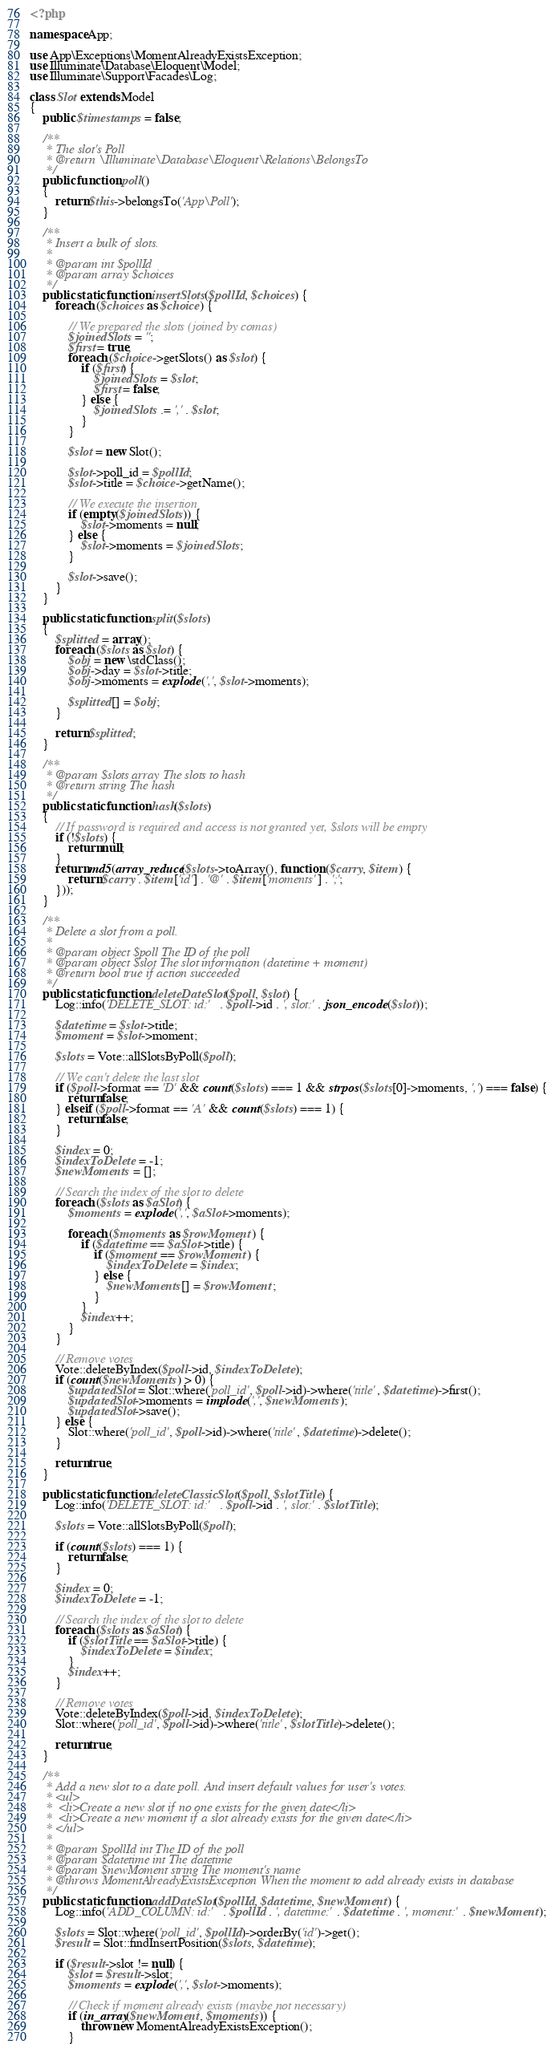<code> <loc_0><loc_0><loc_500><loc_500><_PHP_><?php

namespace App;

use App\Exceptions\MomentAlreadyExistsException;
use Illuminate\Database\Eloquent\Model;
use Illuminate\Support\Facades\Log;

class Slot extends Model
{
    public $timestamps = false;

    /**
     * The slot's Poll
     * @return \Illuminate\Database\Eloquent\Relations\BelongsTo
     */
    public function poll()
    {
        return $this->belongsTo('App\Poll');
    }

    /**
     * Insert a bulk of slots.
     *
     * @param int $pollId
     * @param array $choices
     */
    public static function insertSlots($pollId, $choices) {
        foreach ($choices as $choice) {

            // We prepared the slots (joined by comas)
            $joinedSlots = '';
            $first = true;
            foreach ($choice->getSlots() as $slot) {
                if ($first) {
                    $joinedSlots = $slot;
                    $first = false;
                } else {
                    $joinedSlots .= ',' . $slot;
                }
            }

            $slot = new Slot();

            $slot->poll_id = $pollId;
            $slot->title = $choice->getName();

            // We execute the insertion
            if (empty($joinedSlots)) {
                $slot->moments = null;
            } else {
                $slot->moments = $joinedSlots;
            }

            $slot->save();
        }
    }

    public static function split($slots)
    {
        $splitted = array();
        foreach ($slots as $slot) {
            $obj = new \stdClass();
            $obj->day = $slot->title;
            $obj->moments = explode(',', $slot->moments);

            $splitted[] = $obj;
        }

        return $splitted;
    }

    /**
     * @param $slots array The slots to hash
     * @return string The hash
     */
    public static function hash($slots)
    {
        // If password is required and access is not granted yet, $slots will be empty
        if (!$slots) {
            return null;
        }
        return md5(array_reduce($slots->toArray(), function ($carry, $item) {
            return $carry . $item['id'] . '@' . $item['moments'] . ';';
        }));
    }

    /**
     * Delete a slot from a poll.
     *
     * @param object $poll The ID of the poll
     * @param object $slot The slot information (datetime + moment)
     * @return bool true if action succeeded
     */
    public static function deleteDateSlot($poll, $slot) {
        Log::info('DELETE_SLOT: id:' . $poll->id . ', slot:' . json_encode($slot));

        $datetime = $slot->title;
        $moment = $slot->moment;

        $slots = Vote::allSlotsByPoll($poll);

        // We can't delete the last slot
        if ($poll->format == 'D' && count($slots) === 1 && strpos($slots[0]->moments, ',') === false) {
            return false;
        } elseif ($poll->format == 'A' && count($slots) === 1) {
            return false;
        }

        $index = 0;
        $indexToDelete = -1;
        $newMoments = [];

        // Search the index of the slot to delete
        foreach ($slots as $aSlot) {
            $moments = explode(',', $aSlot->moments);

            foreach ($moments as $rowMoment) {
                if ($datetime == $aSlot->title) {
                    if ($moment == $rowMoment) {
                        $indexToDelete = $index;
                    } else {
                        $newMoments[] = $rowMoment;
                    }
                }
                $index++;
            }
        }

        // Remove votes
        Vote::deleteByIndex($poll->id, $indexToDelete);
        if (count($newMoments) > 0) {
            $updatedSlot = Slot::where('poll_id', $poll->id)->where('title', $datetime)->first();
            $updatedSlot->moments = implode(',', $newMoments);
            $updatedSlot->save();
        } else {
            Slot::where('poll_id', $poll->id)->where('title', $datetime)->delete();
        }

        return true;
    }

    public static function deleteClassicSlot($poll, $slotTitle) {
        Log::info('DELETE_SLOT: id:' . $poll->id . ', slot:' . $slotTitle);

        $slots = Vote::allSlotsByPoll($poll);

        if (count($slots) === 1) {
            return false;
        }

        $index = 0;
        $indexToDelete = -1;

        // Search the index of the slot to delete
        foreach ($slots as $aSlot) {
            if ($slotTitle == $aSlot->title) {
                $indexToDelete = $index;
            }
            $index++;
        }

        // Remove votes
        Vote::deleteByIndex($poll->id, $indexToDelete);
        Slot::where('poll_id', $poll->id)->where('title', $slotTitle)->delete();

        return true;
    }

    /**
     * Add a new slot to a date poll. And insert default values for user's votes.
     * <ul>
     *  <li>Create a new slot if no one exists for the given date</li>
     *  <li>Create a new moment if a slot already exists for the given date</li>
     * </ul>
     *
     * @param $pollId int The ID of the poll
     * @param $datetime int The datetime
     * @param $newMoment string The moment's name
     * @throws MomentAlreadyExistsException When the moment to add already exists in database
     */
    public static function addDateSlot($pollId, $datetime, $newMoment) {
        Log::info('ADD_COLUMN: id:' . $pollId . ', datetime:' . $datetime . ', moment:' . $newMoment);

        $slots = Slot::where('poll_id', $pollId)->orderBy('id')->get();
        $result = Slot::findInsertPosition($slots, $datetime);

        if ($result->slot != null) {
            $slot = $result->slot;
            $moments = explode(',', $slot->moments);

            // Check if moment already exists (maybe not necessary)
            if (in_array($newMoment, $moments)) {
                throw new MomentAlreadyExistsException();
            }
</code> 